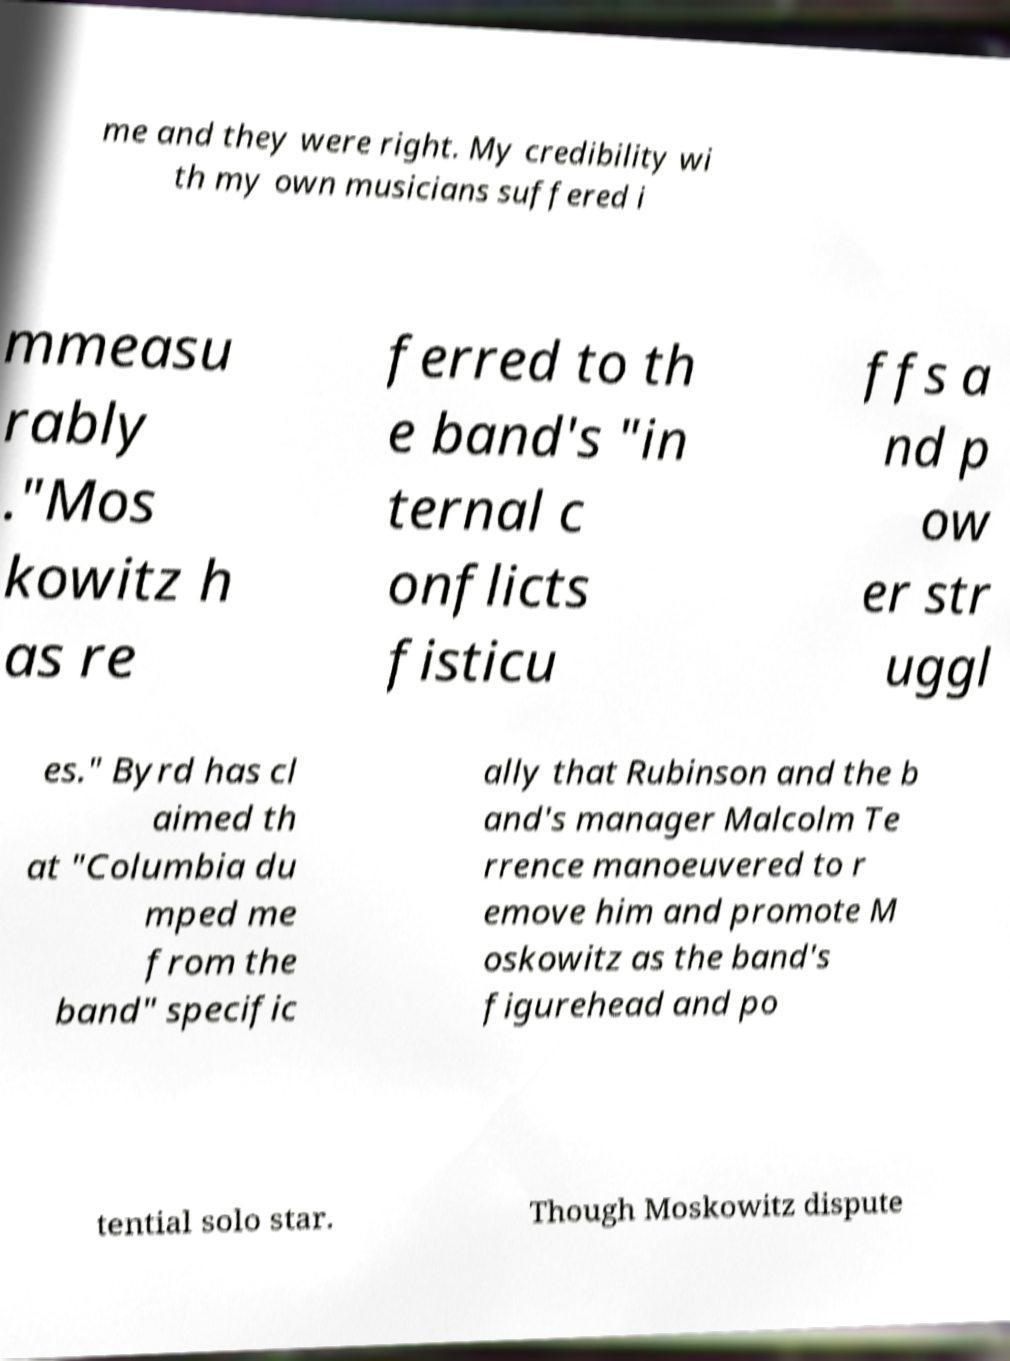Could you extract and type out the text from this image? me and they were right. My credibility wi th my own musicians suffered i mmeasu rably ."Mos kowitz h as re ferred to th e band's "in ternal c onflicts fisticu ffs a nd p ow er str uggl es." Byrd has cl aimed th at "Columbia du mped me from the band" specific ally that Rubinson and the b and's manager Malcolm Te rrence manoeuvered to r emove him and promote M oskowitz as the band's figurehead and po tential solo star. Though Moskowitz dispute 